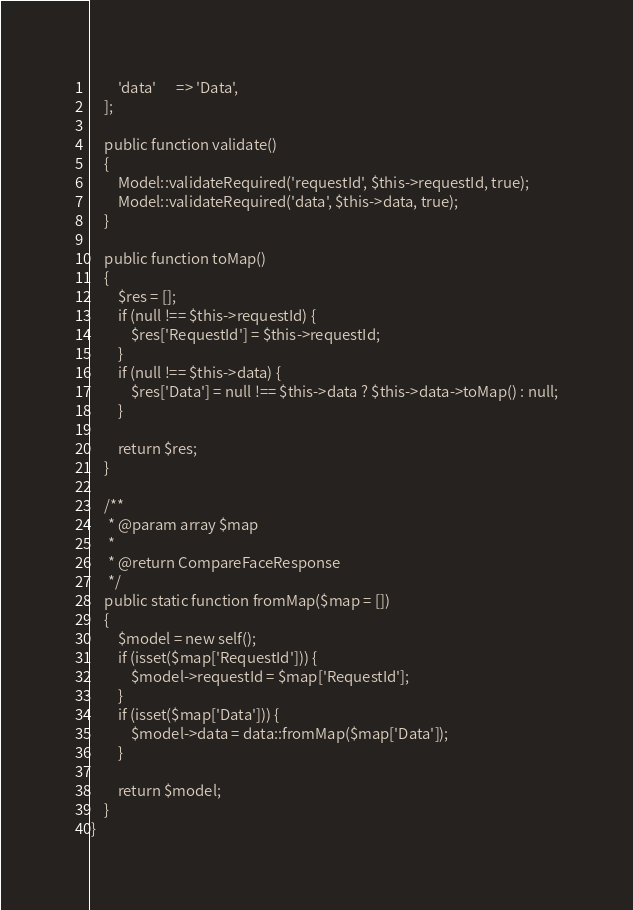Convert code to text. <code><loc_0><loc_0><loc_500><loc_500><_PHP_>        'data'      => 'Data',
    ];

    public function validate()
    {
        Model::validateRequired('requestId', $this->requestId, true);
        Model::validateRequired('data', $this->data, true);
    }

    public function toMap()
    {
        $res = [];
        if (null !== $this->requestId) {
            $res['RequestId'] = $this->requestId;
        }
        if (null !== $this->data) {
            $res['Data'] = null !== $this->data ? $this->data->toMap() : null;
        }

        return $res;
    }

    /**
     * @param array $map
     *
     * @return CompareFaceResponse
     */
    public static function fromMap($map = [])
    {
        $model = new self();
        if (isset($map['RequestId'])) {
            $model->requestId = $map['RequestId'];
        }
        if (isset($map['Data'])) {
            $model->data = data::fromMap($map['Data']);
        }

        return $model;
    }
}
</code> 